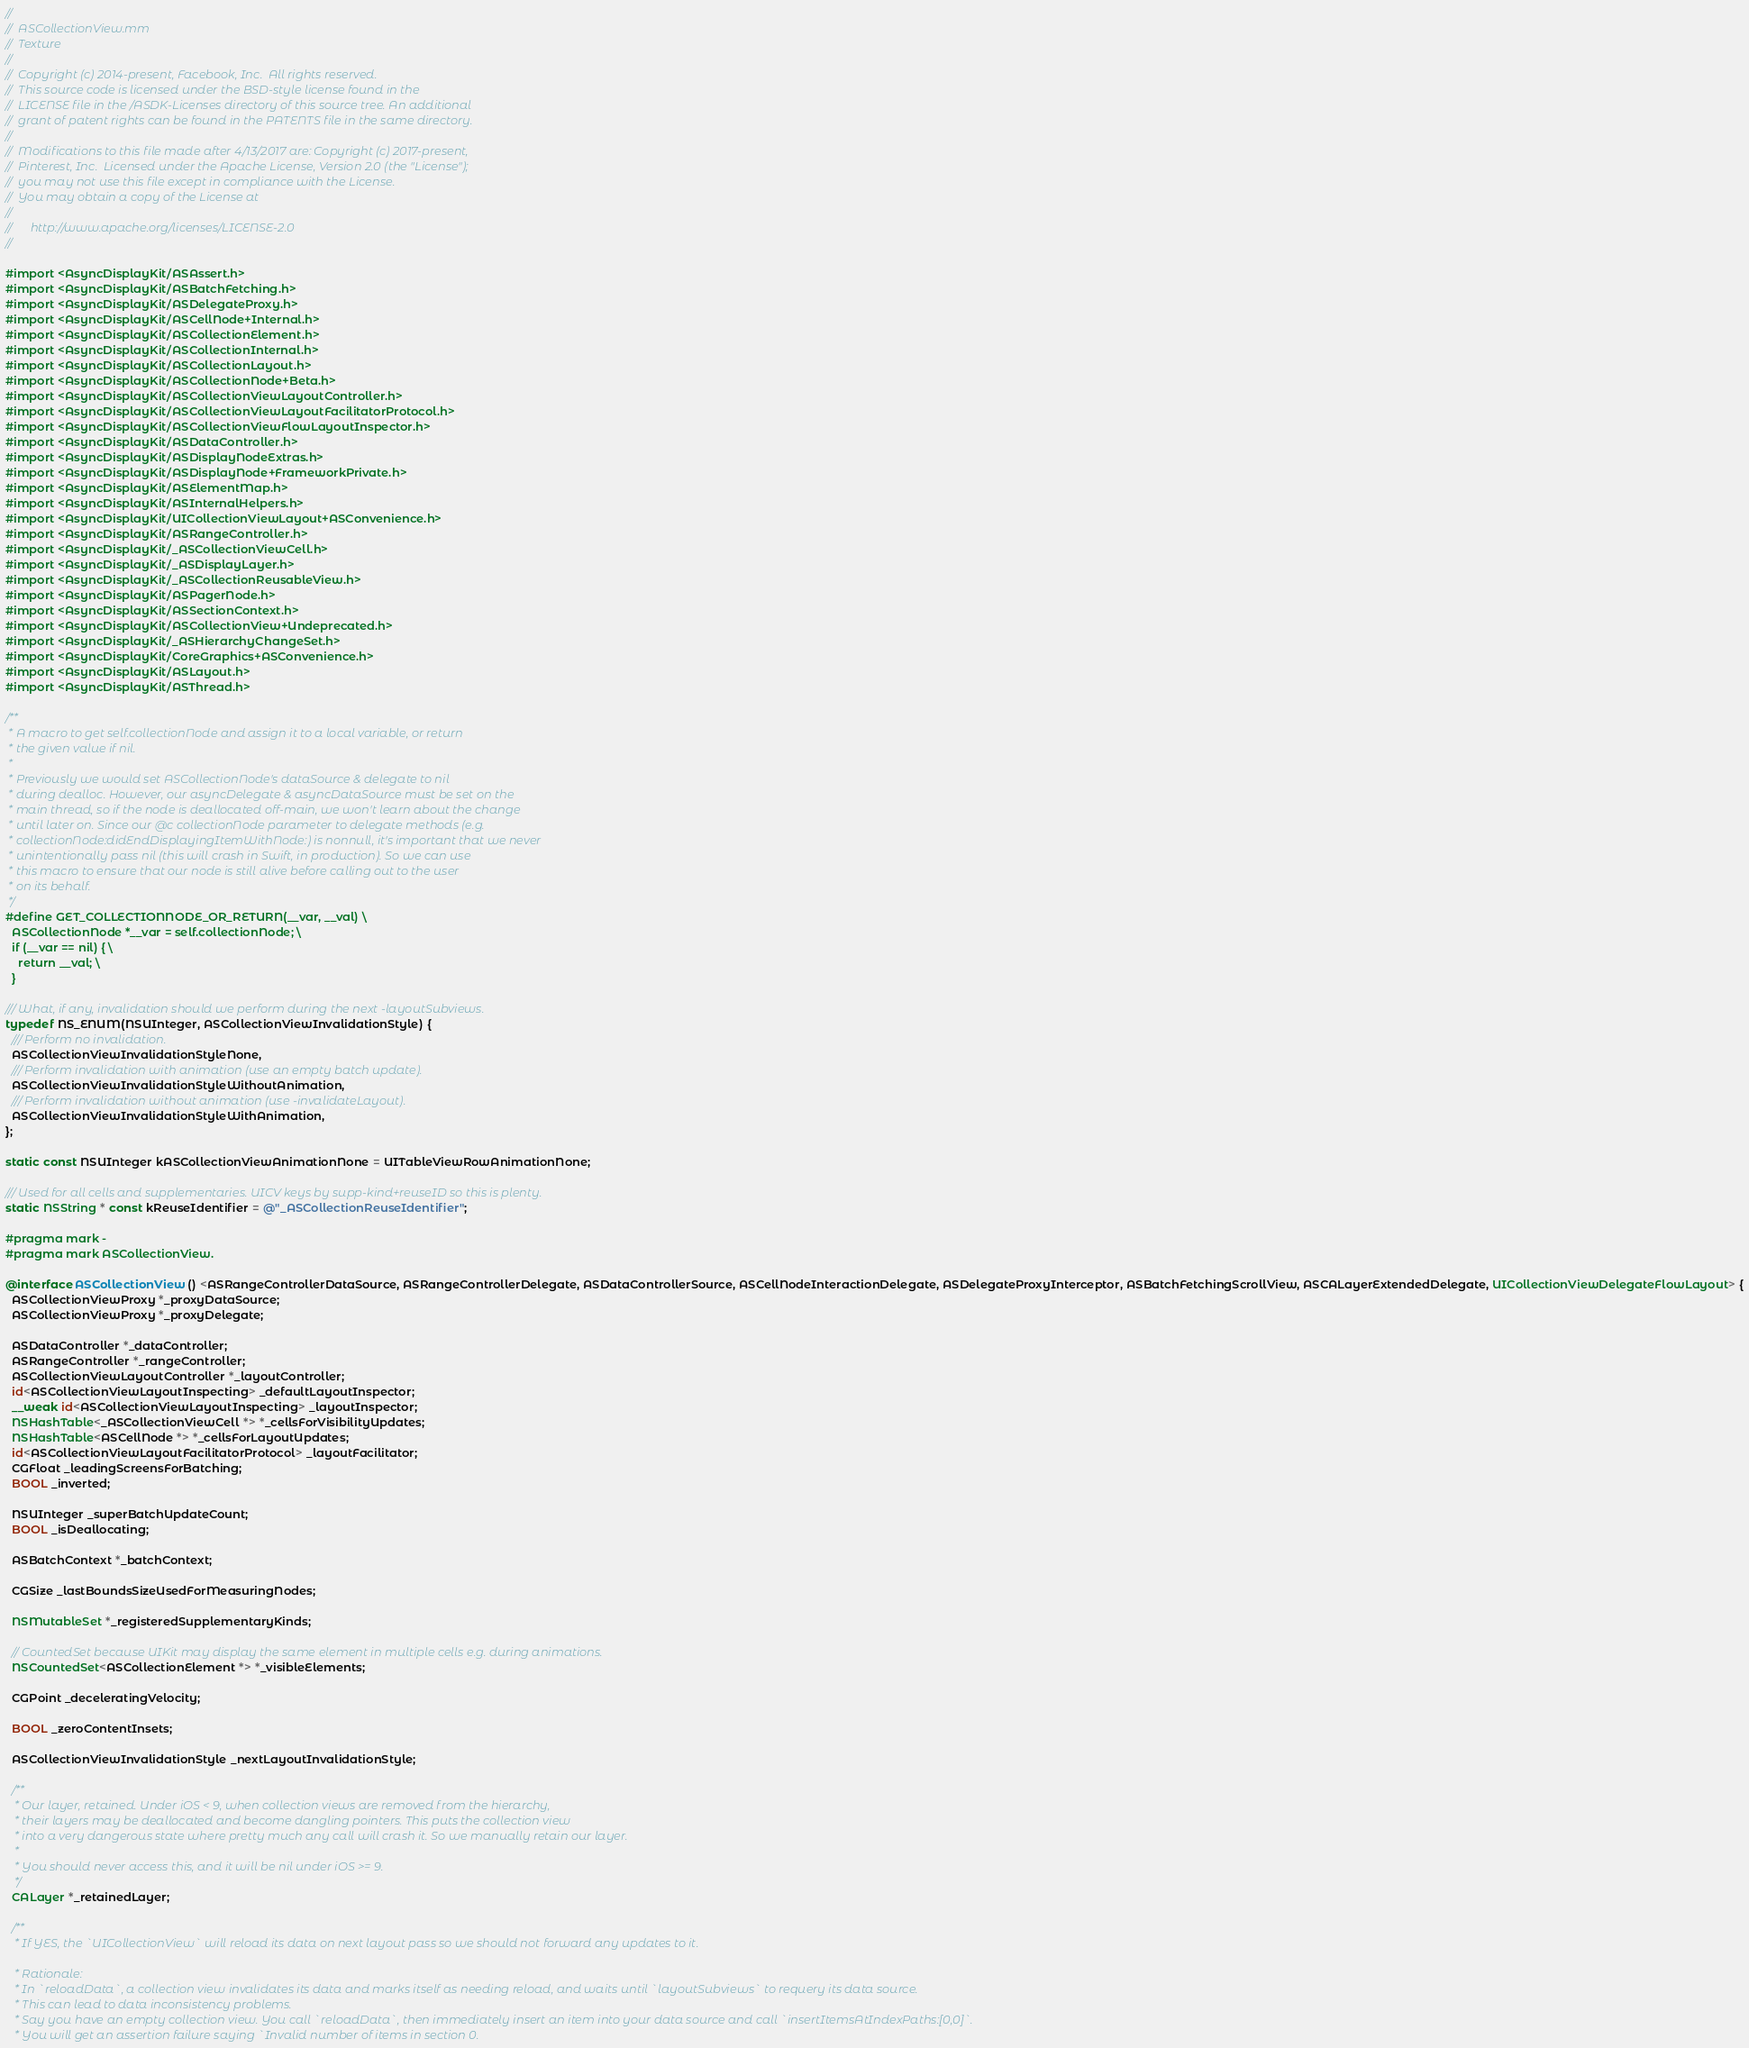<code> <loc_0><loc_0><loc_500><loc_500><_ObjectiveC_>//
//  ASCollectionView.mm
//  Texture
//
//  Copyright (c) 2014-present, Facebook, Inc.  All rights reserved.
//  This source code is licensed under the BSD-style license found in the
//  LICENSE file in the /ASDK-Licenses directory of this source tree. An additional
//  grant of patent rights can be found in the PATENTS file in the same directory.
//
//  Modifications to this file made after 4/13/2017 are: Copyright (c) 2017-present,
//  Pinterest, Inc.  Licensed under the Apache License, Version 2.0 (the "License");
//  you may not use this file except in compliance with the License.
//  You may obtain a copy of the License at
//
//      http://www.apache.org/licenses/LICENSE-2.0
//

#import <AsyncDisplayKit/ASAssert.h>
#import <AsyncDisplayKit/ASBatchFetching.h>
#import <AsyncDisplayKit/ASDelegateProxy.h>
#import <AsyncDisplayKit/ASCellNode+Internal.h>
#import <AsyncDisplayKit/ASCollectionElement.h>
#import <AsyncDisplayKit/ASCollectionInternal.h>
#import <AsyncDisplayKit/ASCollectionLayout.h>
#import <AsyncDisplayKit/ASCollectionNode+Beta.h>
#import <AsyncDisplayKit/ASCollectionViewLayoutController.h>
#import <AsyncDisplayKit/ASCollectionViewLayoutFacilitatorProtocol.h>
#import <AsyncDisplayKit/ASCollectionViewFlowLayoutInspector.h>
#import <AsyncDisplayKit/ASDataController.h>
#import <AsyncDisplayKit/ASDisplayNodeExtras.h>
#import <AsyncDisplayKit/ASDisplayNode+FrameworkPrivate.h>
#import <AsyncDisplayKit/ASElementMap.h>
#import <AsyncDisplayKit/ASInternalHelpers.h>
#import <AsyncDisplayKit/UICollectionViewLayout+ASConvenience.h>
#import <AsyncDisplayKit/ASRangeController.h>
#import <AsyncDisplayKit/_ASCollectionViewCell.h>
#import <AsyncDisplayKit/_ASDisplayLayer.h>
#import <AsyncDisplayKit/_ASCollectionReusableView.h>
#import <AsyncDisplayKit/ASPagerNode.h>
#import <AsyncDisplayKit/ASSectionContext.h>
#import <AsyncDisplayKit/ASCollectionView+Undeprecated.h>
#import <AsyncDisplayKit/_ASHierarchyChangeSet.h>
#import <AsyncDisplayKit/CoreGraphics+ASConvenience.h>
#import <AsyncDisplayKit/ASLayout.h>
#import <AsyncDisplayKit/ASThread.h>

/**
 * A macro to get self.collectionNode and assign it to a local variable, or return
 * the given value if nil.
 *
 * Previously we would set ASCollectionNode's dataSource & delegate to nil
 * during dealloc. However, our asyncDelegate & asyncDataSource must be set on the
 * main thread, so if the node is deallocated off-main, we won't learn about the change
 * until later on. Since our @c collectionNode parameter to delegate methods (e.g.
 * collectionNode:didEndDisplayingItemWithNode:) is nonnull, it's important that we never
 * unintentionally pass nil (this will crash in Swift, in production). So we can use
 * this macro to ensure that our node is still alive before calling out to the user
 * on its behalf.
 */
#define GET_COLLECTIONNODE_OR_RETURN(__var, __val) \
  ASCollectionNode *__var = self.collectionNode; \
  if (__var == nil) { \
    return __val; \
  }

/// What, if any, invalidation should we perform during the next -layoutSubviews.
typedef NS_ENUM(NSUInteger, ASCollectionViewInvalidationStyle) {
  /// Perform no invalidation.
  ASCollectionViewInvalidationStyleNone,
  /// Perform invalidation with animation (use an empty batch update).
  ASCollectionViewInvalidationStyleWithoutAnimation,
  /// Perform invalidation without animation (use -invalidateLayout).
  ASCollectionViewInvalidationStyleWithAnimation,
};

static const NSUInteger kASCollectionViewAnimationNone = UITableViewRowAnimationNone;

/// Used for all cells and supplementaries. UICV keys by supp-kind+reuseID so this is plenty.
static NSString * const kReuseIdentifier = @"_ASCollectionReuseIdentifier";

#pragma mark -
#pragma mark ASCollectionView.

@interface ASCollectionView () <ASRangeControllerDataSource, ASRangeControllerDelegate, ASDataControllerSource, ASCellNodeInteractionDelegate, ASDelegateProxyInterceptor, ASBatchFetchingScrollView, ASCALayerExtendedDelegate, UICollectionViewDelegateFlowLayout> {
  ASCollectionViewProxy *_proxyDataSource;
  ASCollectionViewProxy *_proxyDelegate;
  
  ASDataController *_dataController;
  ASRangeController *_rangeController;
  ASCollectionViewLayoutController *_layoutController;
  id<ASCollectionViewLayoutInspecting> _defaultLayoutInspector;
  __weak id<ASCollectionViewLayoutInspecting> _layoutInspector;
  NSHashTable<_ASCollectionViewCell *> *_cellsForVisibilityUpdates;
  NSHashTable<ASCellNode *> *_cellsForLayoutUpdates;
  id<ASCollectionViewLayoutFacilitatorProtocol> _layoutFacilitator;
  CGFloat _leadingScreensForBatching;
  BOOL _inverted;
  
  NSUInteger _superBatchUpdateCount;
  BOOL _isDeallocating;
  
  ASBatchContext *_batchContext;
  
  CGSize _lastBoundsSizeUsedForMeasuringNodes;
  
  NSMutableSet *_registeredSupplementaryKinds;
  
  // CountedSet because UIKit may display the same element in multiple cells e.g. during animations.
  NSCountedSet<ASCollectionElement *> *_visibleElements;
  
  CGPoint _deceleratingVelocity;

  BOOL _zeroContentInsets;
  
  ASCollectionViewInvalidationStyle _nextLayoutInvalidationStyle;
  
  /**
   * Our layer, retained. Under iOS < 9, when collection views are removed from the hierarchy,
   * their layers may be deallocated and become dangling pointers. This puts the collection view
   * into a very dangerous state where pretty much any call will crash it. So we manually retain our layer.
   *
   * You should never access this, and it will be nil under iOS >= 9.
   */
  CALayer *_retainedLayer;
  
  /**
   * If YES, the `UICollectionView` will reload its data on next layout pass so we should not forward any updates to it.
   
   * Rationale:
   * In `reloadData`, a collection view invalidates its data and marks itself as needing reload, and waits until `layoutSubviews` to requery its data source.
   * This can lead to data inconsistency problems.
   * Say you have an empty collection view. You call `reloadData`, then immediately insert an item into your data source and call `insertItemsAtIndexPaths:[0,0]`.
   * You will get an assertion failure saying `Invalid number of items in section 0.</code> 